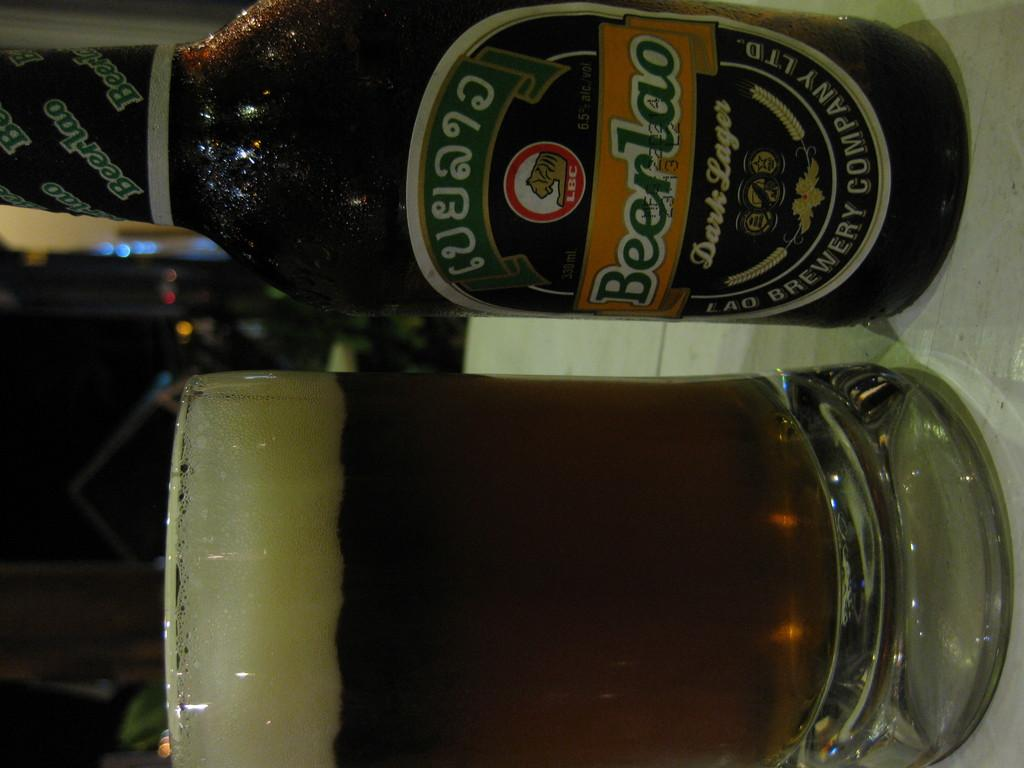<image>
Describe the image concisely. A dark lager beer was poured into a beer glass. 